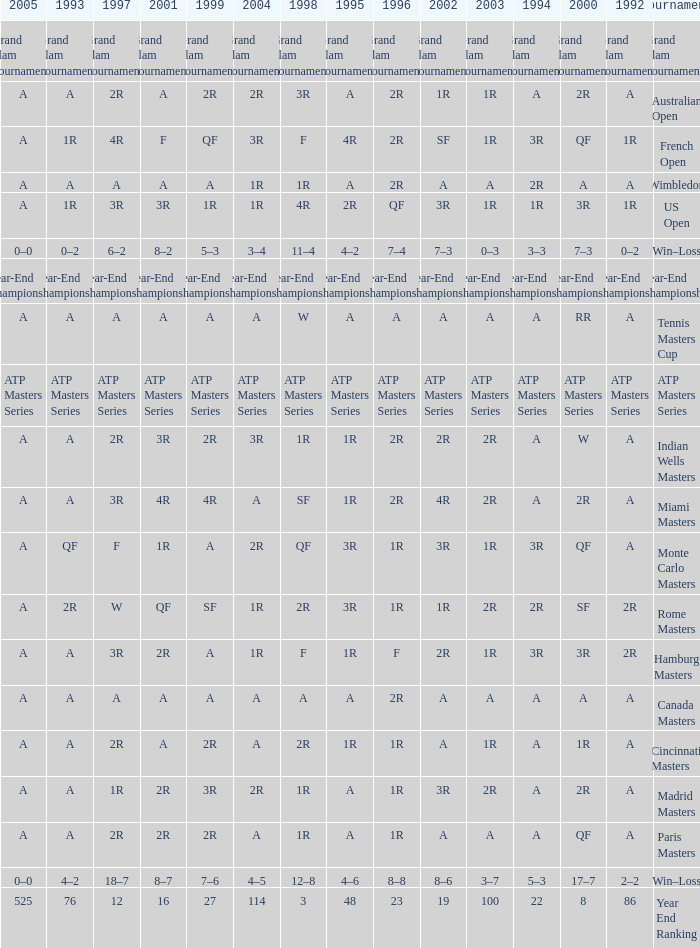What is 1992, when 1999 is "Year-End Championship"? Year-End Championship. 